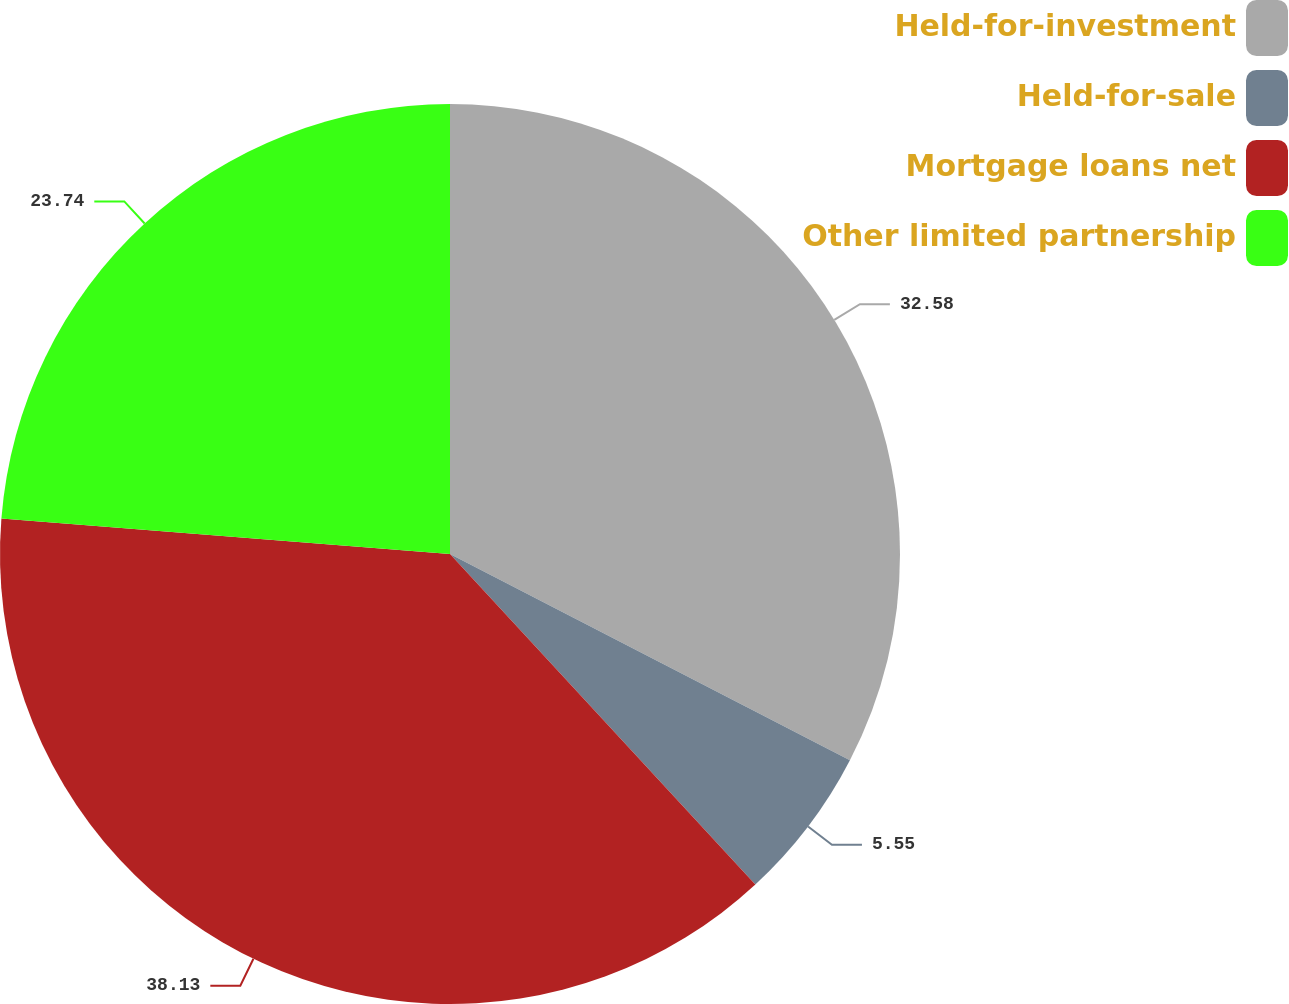Convert chart to OTSL. <chart><loc_0><loc_0><loc_500><loc_500><pie_chart><fcel>Held-for-investment<fcel>Held-for-sale<fcel>Mortgage loans net<fcel>Other limited partnership<nl><fcel>32.58%<fcel>5.55%<fcel>38.13%<fcel>23.74%<nl></chart> 